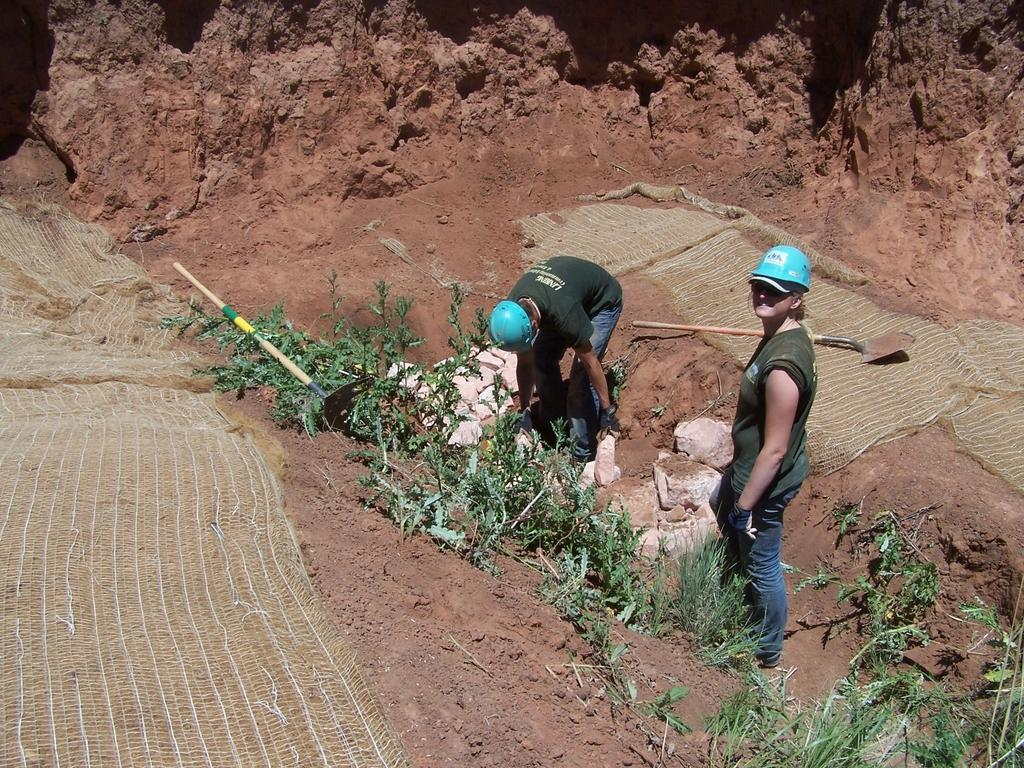How many people are in the image? There are two people in the image. What are the people wearing on their heads? The people are wearing helmets. What type of natural elements can be seen in the image? There are rocks and plants in the image. Can you describe any other elements in the image? There are other unspecified elements in the image. What color are the bikes in the image? There are no bikes present in the image. How does the edge of the cliff affect the people in the image? There is no mention of a cliff in the image, so it's not possible to answer how the edge of a cliff might affect the people. 